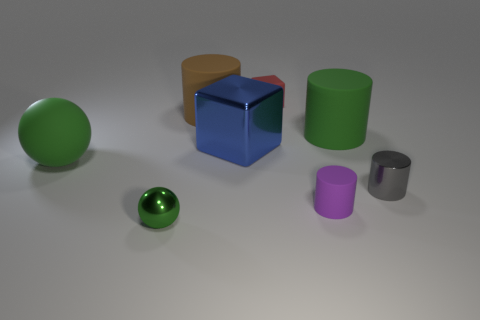Is the color of the sphere that is left of the small sphere the same as the tiny thing to the left of the blue metal object?
Offer a very short reply. Yes. What material is the gray cylinder?
Provide a short and direct response. Metal. What number of blue cubes are the same size as the red cube?
Offer a terse response. 0. Are there an equal number of small purple rubber cylinders to the left of the purple rubber cylinder and large things that are to the left of the green metal thing?
Offer a terse response. No. Are the big brown cylinder and the big blue thing made of the same material?
Offer a very short reply. No. There is a ball in front of the gray shiny cylinder; are there any large green rubber things that are left of it?
Your response must be concise. Yes. Is there a green thing of the same shape as the big brown matte thing?
Your answer should be compact. Yes. Does the big ball have the same color as the tiny sphere?
Give a very brief answer. Yes. What is the material of the tiny object that is left of the metallic thing that is behind the tiny gray metallic cylinder?
Offer a terse response. Metal. How big is the blue metal block?
Your answer should be very brief. Large. 